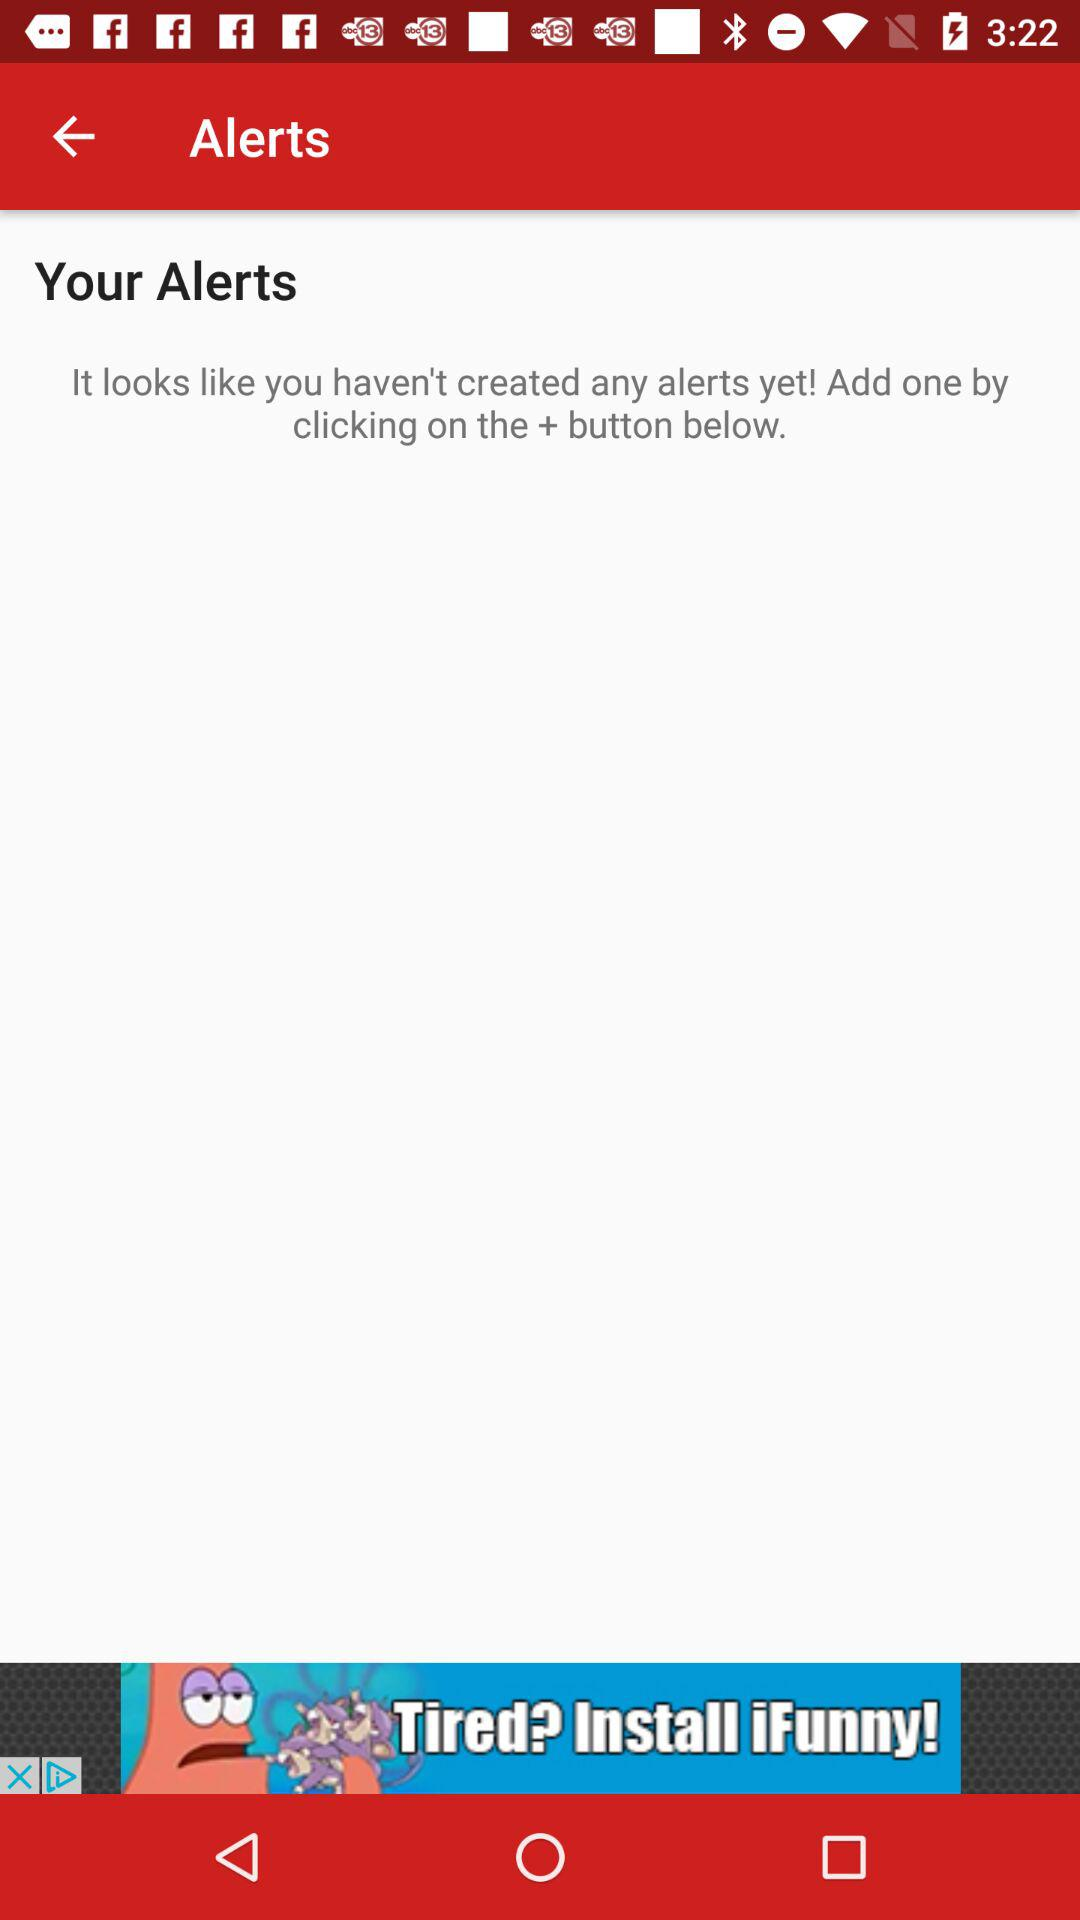How many alerts have been created?
Answer the question using a single word or phrase. 0 